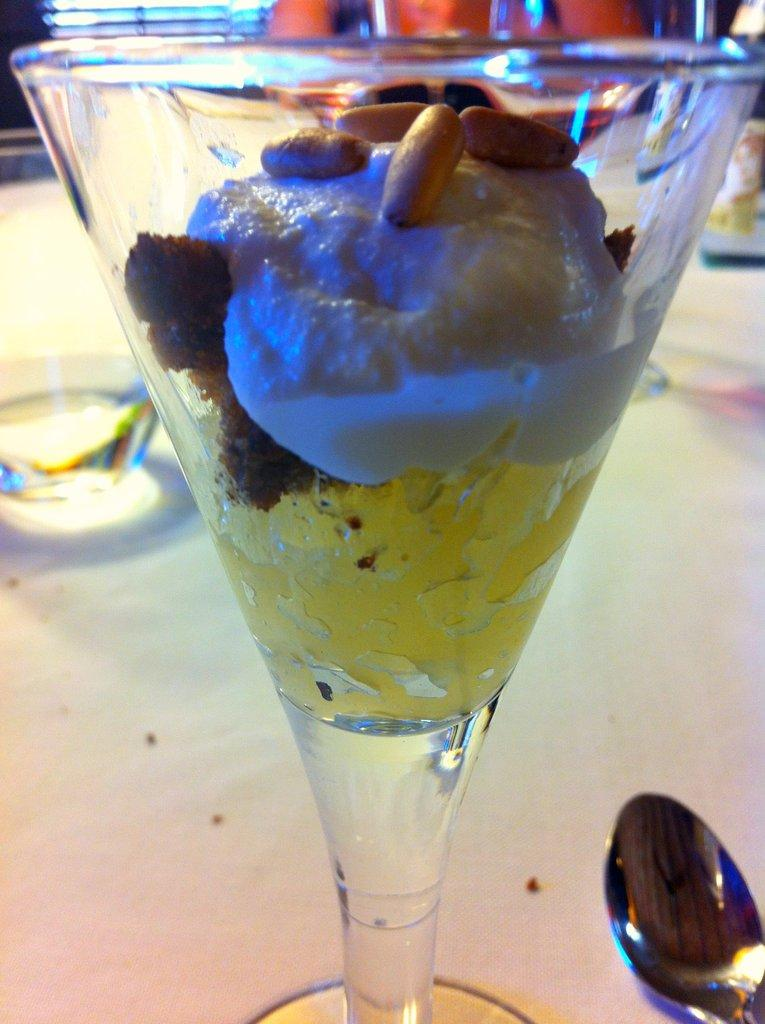What is in the glass that is visible in the image? There is a glass filled with food items in the image. Where is the nearest airport to the location of the glass in the image? There is no information about the location of the glass or the nearest airport in the image. How many chickens can be seen in the image? There are no chickens present in the image. 